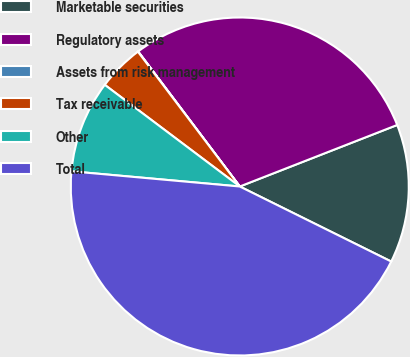Convert chart to OTSL. <chart><loc_0><loc_0><loc_500><loc_500><pie_chart><fcel>Marketable securities<fcel>Regulatory assets<fcel>Assets from risk management<fcel>Tax receivable<fcel>Other<fcel>Total<nl><fcel>13.25%<fcel>29.34%<fcel>0.03%<fcel>4.43%<fcel>8.84%<fcel>44.11%<nl></chart> 